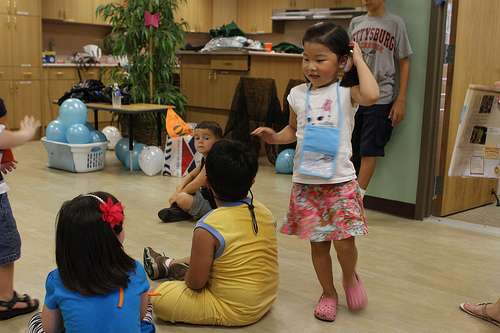<image>
Is there a baby to the right of the ball? Yes. From this viewpoint, the baby is positioned to the right side relative to the ball. 